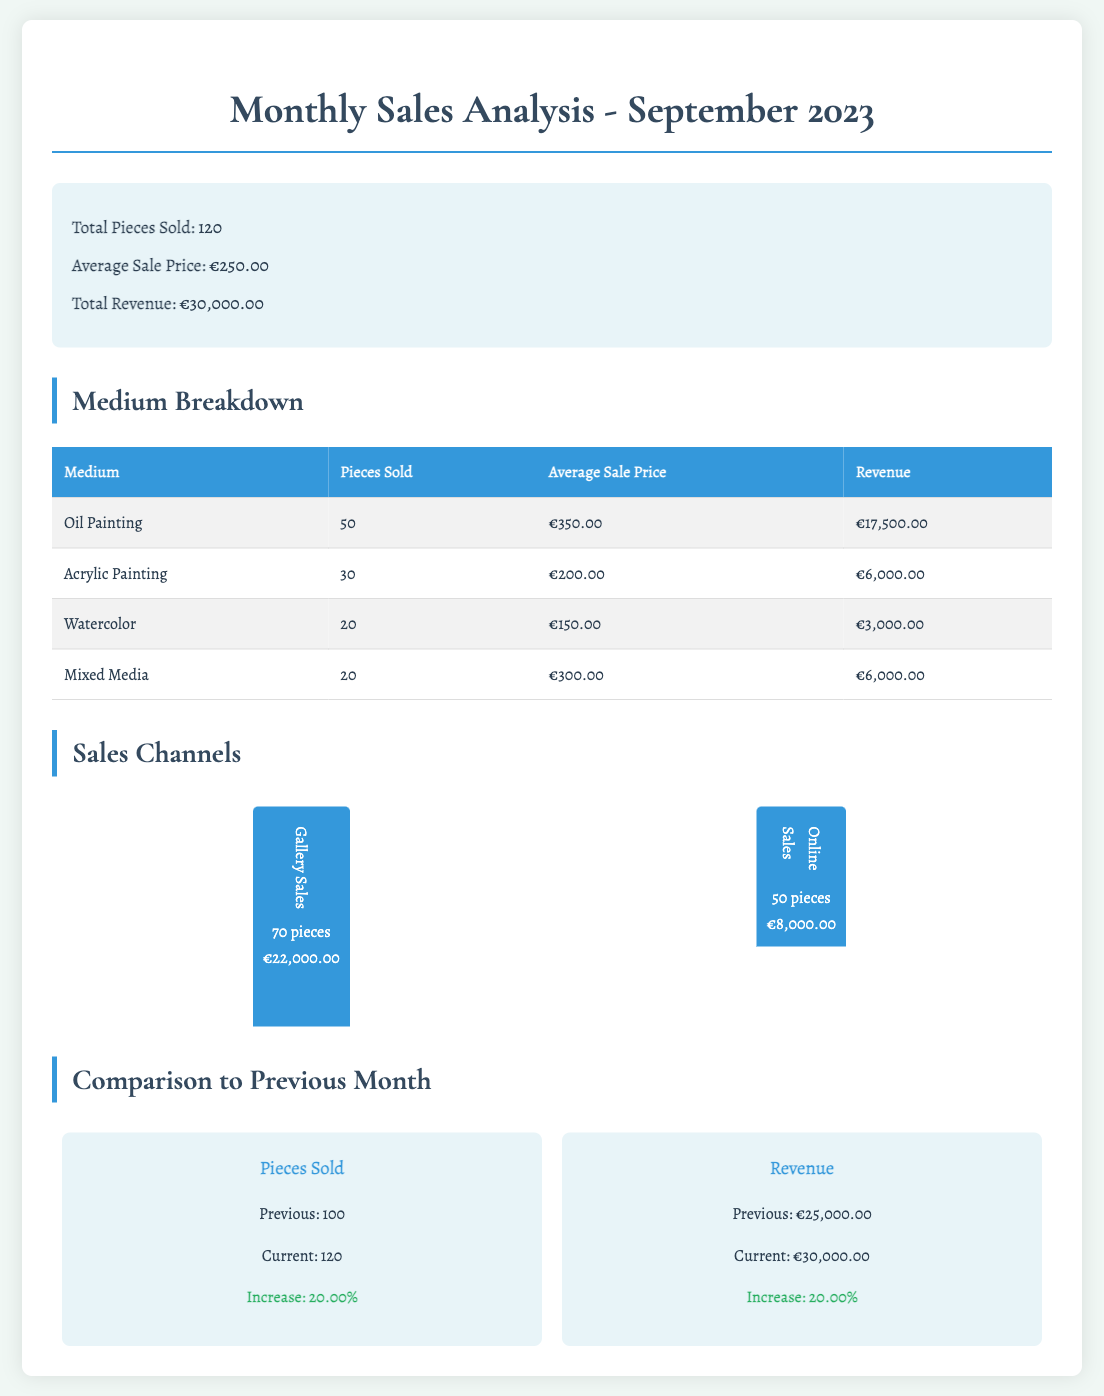What is the total revenue? The total revenue is provided in the summary section of the document.
Answer: €30,000.00 How many pieces were sold in total? The total pieces sold is mentioned in the summary of the document.
Answer: 120 What is the average sale price? The average sale price is listed in the summary section.
Answer: €250.00 Which medium had the highest revenue? The medium breakdown table shows that Oil Painting had the highest revenue.
Answer: Oil Painting How many pieces sold through Gallery Sales? The chart for Sales Channels states the number of pieces sold through Gallery Sales.
Answer: 70 pieces What was the revenue from Online Sales? The Sales Channels section specifies the revenue generated from Online Sales.
Answer: €8,000.00 What is the increase in pieces sold compared to the previous month? The comparison section lists the current and previous month's pieces sold, along with the increase.
Answer: 20.00% What was the average sale price for Watercolor? The Medium Breakdown table provides the average sale price for Watercolor.
Answer: €150.00 What was the previous month's revenue? The comparison section indicates the previous month's total revenue.
Answer: €25,000.00 